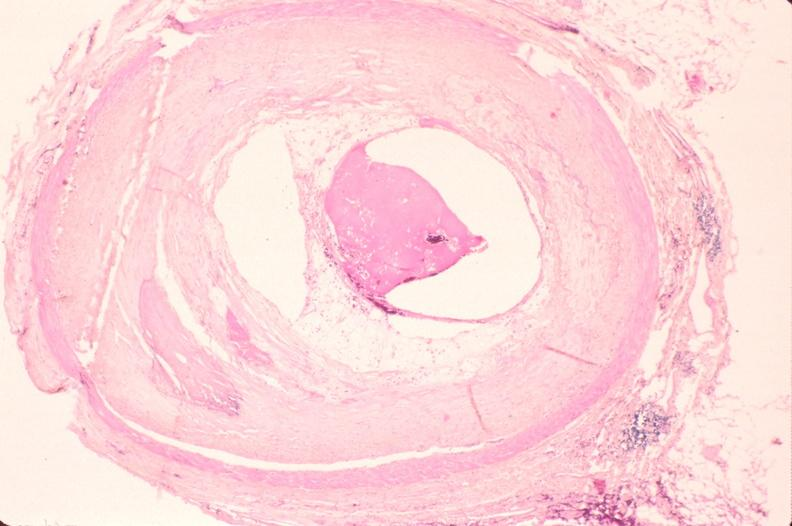s surface present?
Answer the question using a single word or phrase. No 